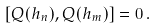<formula> <loc_0><loc_0><loc_500><loc_500>[ Q ( h _ { n } ) , Q ( h _ { m } ) ] = 0 \, .</formula> 